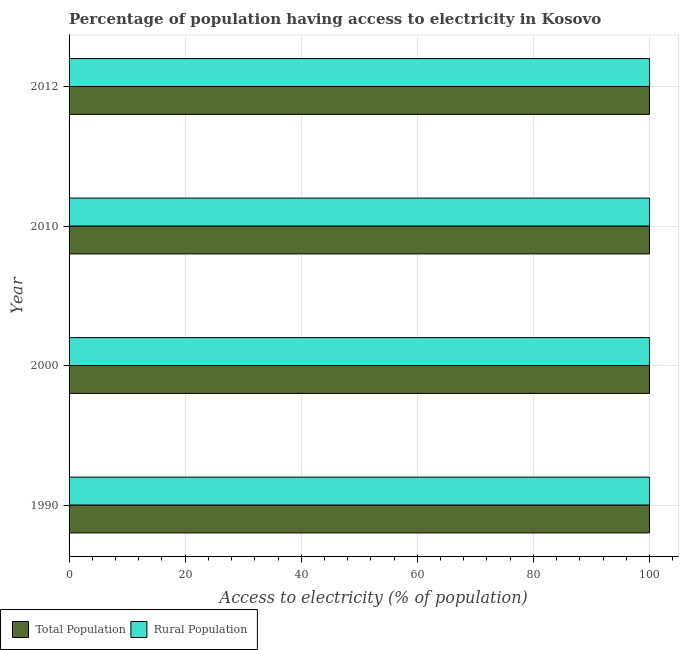Are the number of bars on each tick of the Y-axis equal?
Provide a succinct answer. Yes. How many bars are there on the 2nd tick from the top?
Your answer should be very brief. 2. In how many cases, is the number of bars for a given year not equal to the number of legend labels?
Your answer should be very brief. 0. What is the percentage of rural population having access to electricity in 1990?
Offer a terse response. 100. Across all years, what is the maximum percentage of population having access to electricity?
Make the answer very short. 100. Across all years, what is the minimum percentage of population having access to electricity?
Offer a very short reply. 100. In which year was the percentage of rural population having access to electricity maximum?
Make the answer very short. 1990. In which year was the percentage of population having access to electricity minimum?
Offer a terse response. 1990. What is the total percentage of population having access to electricity in the graph?
Provide a succinct answer. 400. What is the difference between the percentage of rural population having access to electricity in 2010 and that in 2012?
Keep it short and to the point. 0. What is the difference between the percentage of rural population having access to electricity in 2000 and the percentage of population having access to electricity in 2010?
Your answer should be very brief. 0. In the year 2010, what is the difference between the percentage of rural population having access to electricity and percentage of population having access to electricity?
Offer a terse response. 0. Is the percentage of rural population having access to electricity in 2000 less than that in 2010?
Offer a very short reply. No. What is the difference between the highest and the second highest percentage of rural population having access to electricity?
Ensure brevity in your answer.  0. What is the difference between the highest and the lowest percentage of rural population having access to electricity?
Ensure brevity in your answer.  0. In how many years, is the percentage of rural population having access to electricity greater than the average percentage of rural population having access to electricity taken over all years?
Your answer should be very brief. 0. What does the 2nd bar from the top in 2000 represents?
Your response must be concise. Total Population. What does the 1st bar from the bottom in 1990 represents?
Ensure brevity in your answer.  Total Population. Are the values on the major ticks of X-axis written in scientific E-notation?
Your response must be concise. No. How are the legend labels stacked?
Offer a very short reply. Horizontal. What is the title of the graph?
Your response must be concise. Percentage of population having access to electricity in Kosovo. Does "Official creditors" appear as one of the legend labels in the graph?
Give a very brief answer. No. What is the label or title of the X-axis?
Keep it short and to the point. Access to electricity (% of population). What is the Access to electricity (% of population) in Rural Population in 1990?
Give a very brief answer. 100. What is the Access to electricity (% of population) of Total Population in 2000?
Your response must be concise. 100. What is the Access to electricity (% of population) in Rural Population in 2012?
Give a very brief answer. 100. Across all years, what is the maximum Access to electricity (% of population) of Rural Population?
Your response must be concise. 100. Across all years, what is the minimum Access to electricity (% of population) of Total Population?
Provide a succinct answer. 100. What is the total Access to electricity (% of population) of Total Population in the graph?
Provide a succinct answer. 400. What is the difference between the Access to electricity (% of population) in Total Population in 1990 and that in 2000?
Your answer should be compact. 0. What is the difference between the Access to electricity (% of population) of Rural Population in 1990 and that in 2000?
Offer a very short reply. 0. What is the difference between the Access to electricity (% of population) in Total Population in 1990 and that in 2010?
Your answer should be very brief. 0. What is the difference between the Access to electricity (% of population) of Rural Population in 1990 and that in 2012?
Offer a terse response. 0. What is the difference between the Access to electricity (% of population) of Total Population in 2000 and that in 2010?
Give a very brief answer. 0. What is the difference between the Access to electricity (% of population) in Total Population in 2010 and that in 2012?
Your answer should be compact. 0. What is the difference between the Access to electricity (% of population) in Total Population in 1990 and the Access to electricity (% of population) in Rural Population in 2000?
Offer a very short reply. 0. What is the difference between the Access to electricity (% of population) in Total Population in 1990 and the Access to electricity (% of population) in Rural Population in 2010?
Your answer should be very brief. 0. What is the difference between the Access to electricity (% of population) of Total Population in 1990 and the Access to electricity (% of population) of Rural Population in 2012?
Ensure brevity in your answer.  0. What is the difference between the Access to electricity (% of population) of Total Population in 2000 and the Access to electricity (% of population) of Rural Population in 2010?
Ensure brevity in your answer.  0. What is the difference between the Access to electricity (% of population) in Total Population in 2000 and the Access to electricity (% of population) in Rural Population in 2012?
Provide a short and direct response. 0. What is the difference between the Access to electricity (% of population) of Total Population in 2010 and the Access to electricity (% of population) of Rural Population in 2012?
Your response must be concise. 0. What is the average Access to electricity (% of population) of Total Population per year?
Your answer should be compact. 100. What is the average Access to electricity (% of population) of Rural Population per year?
Give a very brief answer. 100. In the year 1990, what is the difference between the Access to electricity (% of population) of Total Population and Access to electricity (% of population) of Rural Population?
Provide a short and direct response. 0. In the year 2000, what is the difference between the Access to electricity (% of population) in Total Population and Access to electricity (% of population) in Rural Population?
Provide a short and direct response. 0. In the year 2010, what is the difference between the Access to electricity (% of population) of Total Population and Access to electricity (% of population) of Rural Population?
Ensure brevity in your answer.  0. What is the ratio of the Access to electricity (% of population) of Rural Population in 1990 to that in 2000?
Your answer should be compact. 1. What is the ratio of the Access to electricity (% of population) in Total Population in 1990 to that in 2012?
Offer a terse response. 1. What is the ratio of the Access to electricity (% of population) in Rural Population in 1990 to that in 2012?
Provide a succinct answer. 1. What is the ratio of the Access to electricity (% of population) in Rural Population in 2000 to that in 2010?
Give a very brief answer. 1. What is the ratio of the Access to electricity (% of population) of Total Population in 2000 to that in 2012?
Provide a succinct answer. 1. What is the ratio of the Access to electricity (% of population) in Total Population in 2010 to that in 2012?
Ensure brevity in your answer.  1. What is the difference between the highest and the second highest Access to electricity (% of population) of Rural Population?
Give a very brief answer. 0. What is the difference between the highest and the lowest Access to electricity (% of population) in Total Population?
Keep it short and to the point. 0. 